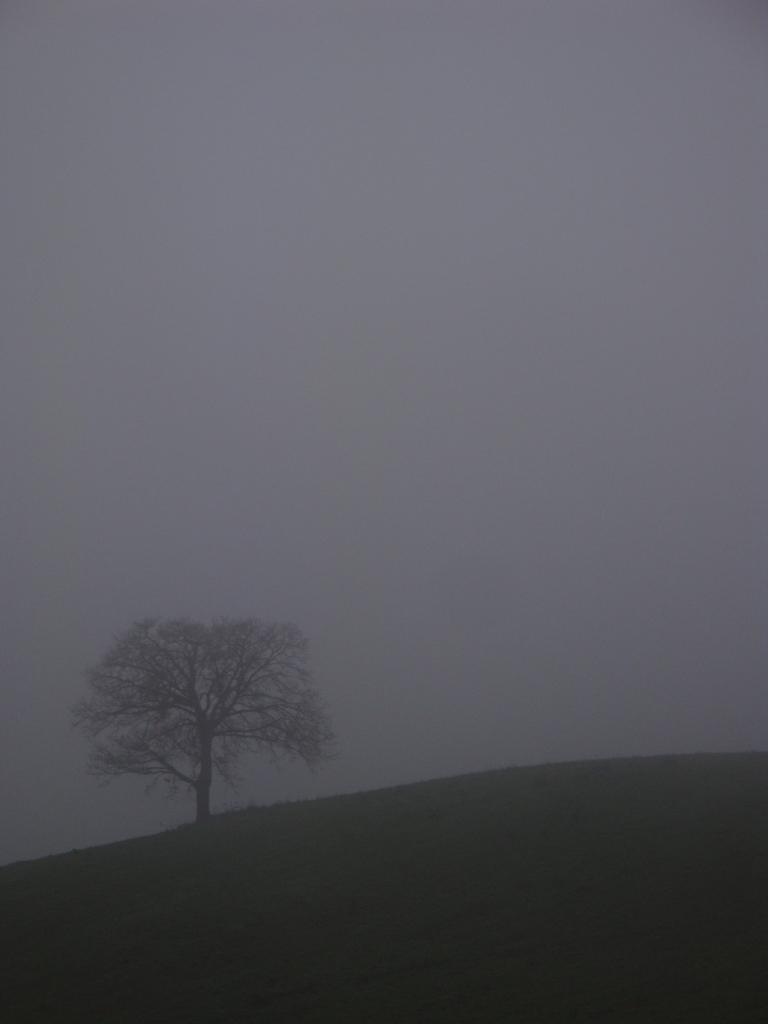Could you give a brief overview of what you see in this image? In this picture I can see sky, tree and ground. 